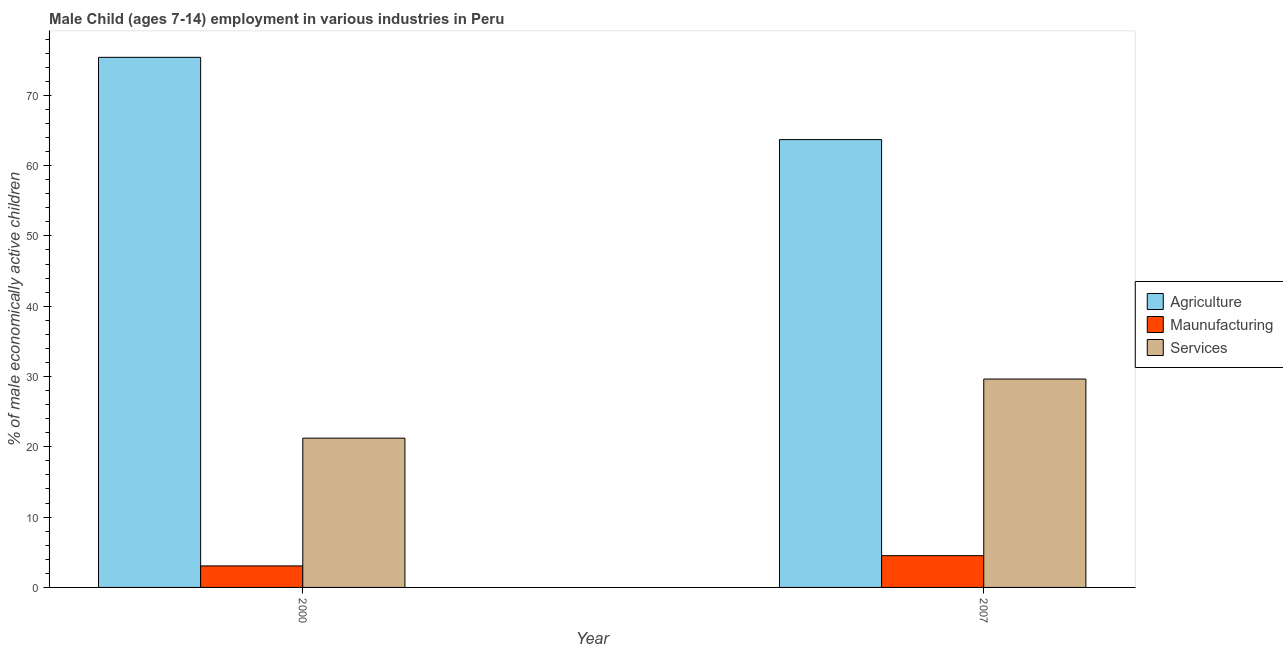How many different coloured bars are there?
Offer a terse response. 3. Are the number of bars on each tick of the X-axis equal?
Offer a terse response. Yes. How many bars are there on the 1st tick from the right?
Ensure brevity in your answer.  3. In how many cases, is the number of bars for a given year not equal to the number of legend labels?
Your answer should be very brief. 0. What is the percentage of economically active children in agriculture in 2000?
Provide a short and direct response. 75.4. Across all years, what is the maximum percentage of economically active children in services?
Your answer should be very brief. 29.64. Across all years, what is the minimum percentage of economically active children in manufacturing?
Provide a succinct answer. 3.06. In which year was the percentage of economically active children in manufacturing maximum?
Offer a terse response. 2007. What is the total percentage of economically active children in manufacturing in the graph?
Your response must be concise. 7.58. What is the difference between the percentage of economically active children in manufacturing in 2000 and that in 2007?
Make the answer very short. -1.46. What is the difference between the percentage of economically active children in manufacturing in 2000 and the percentage of economically active children in services in 2007?
Offer a terse response. -1.46. What is the average percentage of economically active children in manufacturing per year?
Your answer should be compact. 3.79. In how many years, is the percentage of economically active children in services greater than 64 %?
Your answer should be very brief. 0. What is the ratio of the percentage of economically active children in agriculture in 2000 to that in 2007?
Make the answer very short. 1.18. Is the percentage of economically active children in manufacturing in 2000 less than that in 2007?
Your answer should be compact. Yes. In how many years, is the percentage of economically active children in agriculture greater than the average percentage of economically active children in agriculture taken over all years?
Your answer should be very brief. 1. What does the 1st bar from the left in 2007 represents?
Provide a short and direct response. Agriculture. What does the 3rd bar from the right in 2007 represents?
Offer a very short reply. Agriculture. Are all the bars in the graph horizontal?
Provide a succinct answer. No. Does the graph contain any zero values?
Your answer should be compact. No. What is the title of the graph?
Provide a succinct answer. Male Child (ages 7-14) employment in various industries in Peru. Does "Natural gas sources" appear as one of the legend labels in the graph?
Your response must be concise. No. What is the label or title of the Y-axis?
Make the answer very short. % of male economically active children. What is the % of male economically active children of Agriculture in 2000?
Give a very brief answer. 75.4. What is the % of male economically active children in Maunufacturing in 2000?
Provide a succinct answer. 3.06. What is the % of male economically active children in Services in 2000?
Offer a terse response. 21.23. What is the % of male economically active children of Agriculture in 2007?
Make the answer very short. 63.7. What is the % of male economically active children of Maunufacturing in 2007?
Offer a very short reply. 4.52. What is the % of male economically active children in Services in 2007?
Make the answer very short. 29.64. Across all years, what is the maximum % of male economically active children in Agriculture?
Offer a terse response. 75.4. Across all years, what is the maximum % of male economically active children of Maunufacturing?
Ensure brevity in your answer.  4.52. Across all years, what is the maximum % of male economically active children in Services?
Your answer should be compact. 29.64. Across all years, what is the minimum % of male economically active children of Agriculture?
Your answer should be compact. 63.7. Across all years, what is the minimum % of male economically active children in Maunufacturing?
Offer a terse response. 3.06. Across all years, what is the minimum % of male economically active children in Services?
Offer a very short reply. 21.23. What is the total % of male economically active children of Agriculture in the graph?
Your answer should be compact. 139.1. What is the total % of male economically active children of Maunufacturing in the graph?
Provide a short and direct response. 7.58. What is the total % of male economically active children of Services in the graph?
Offer a terse response. 50.87. What is the difference between the % of male economically active children in Maunufacturing in 2000 and that in 2007?
Your answer should be compact. -1.46. What is the difference between the % of male economically active children in Services in 2000 and that in 2007?
Ensure brevity in your answer.  -8.41. What is the difference between the % of male economically active children of Agriculture in 2000 and the % of male economically active children of Maunufacturing in 2007?
Offer a very short reply. 70.88. What is the difference between the % of male economically active children in Agriculture in 2000 and the % of male economically active children in Services in 2007?
Make the answer very short. 45.76. What is the difference between the % of male economically active children in Maunufacturing in 2000 and the % of male economically active children in Services in 2007?
Ensure brevity in your answer.  -26.58. What is the average % of male economically active children in Agriculture per year?
Provide a succinct answer. 69.55. What is the average % of male economically active children in Maunufacturing per year?
Ensure brevity in your answer.  3.79. What is the average % of male economically active children in Services per year?
Provide a short and direct response. 25.43. In the year 2000, what is the difference between the % of male economically active children of Agriculture and % of male economically active children of Maunufacturing?
Make the answer very short. 72.34. In the year 2000, what is the difference between the % of male economically active children in Agriculture and % of male economically active children in Services?
Your answer should be very brief. 54.17. In the year 2000, what is the difference between the % of male economically active children in Maunufacturing and % of male economically active children in Services?
Make the answer very short. -18.17. In the year 2007, what is the difference between the % of male economically active children in Agriculture and % of male economically active children in Maunufacturing?
Give a very brief answer. 59.18. In the year 2007, what is the difference between the % of male economically active children of Agriculture and % of male economically active children of Services?
Make the answer very short. 34.06. In the year 2007, what is the difference between the % of male economically active children in Maunufacturing and % of male economically active children in Services?
Your answer should be very brief. -25.12. What is the ratio of the % of male economically active children of Agriculture in 2000 to that in 2007?
Offer a terse response. 1.18. What is the ratio of the % of male economically active children of Maunufacturing in 2000 to that in 2007?
Offer a very short reply. 0.68. What is the ratio of the % of male economically active children in Services in 2000 to that in 2007?
Offer a terse response. 0.72. What is the difference between the highest and the second highest % of male economically active children in Maunufacturing?
Offer a terse response. 1.46. What is the difference between the highest and the second highest % of male economically active children of Services?
Your response must be concise. 8.41. What is the difference between the highest and the lowest % of male economically active children in Agriculture?
Make the answer very short. 11.7. What is the difference between the highest and the lowest % of male economically active children of Maunufacturing?
Offer a very short reply. 1.46. What is the difference between the highest and the lowest % of male economically active children of Services?
Your response must be concise. 8.41. 